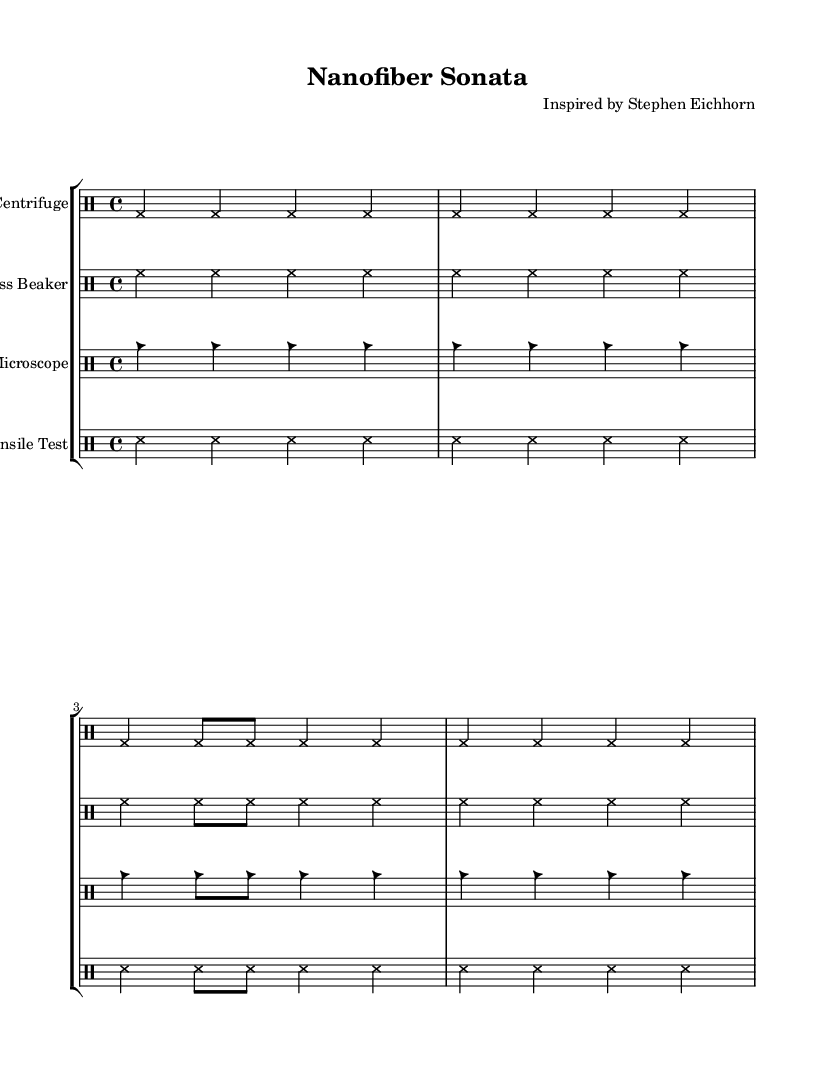What is the time signature of this music? The time signature is indicated by the quarter note beats per measure throughout the piece. Each measure consists of four beats, seen by the grouping of notes that repeat consistently.
Answer: 4/4 What is the instrument name for the first staff? The first staff is labeled as "Centrifuge," which is indicated at the beginning of that staff.
Answer: Centrifuge How many measures are in the "Glass Beaker" section? The "Glass Beaker" section contains four measures, similar to the other staffs in the composition, as indicated by the repeating pattern of the notation.
Answer: 4 Which note head style is used for the "Electron Microscope"? The "Electron Microscope" section uses a style indicated by square note heads, as defined in the code where the note head style is specified.
Answer: Square What instruments are featured in this composition? The instruments are listed at the beginning of each staff, and they include Centrifuge, Glass Beaker, Electron Microscope, and Tensile Test.
Answer: Centrifuge, Glass Beaker, Electron Microscope, Tensile Test Which note type is predominant in the "Tensile Testing Machine"? The notable note type in the "Tensile Testing Machine" is the sixteenth note, which shows the subdivision of the quarter notes and creates a rapid rhythmic texture.
Answer: Sixteenth note What is the overall style of this composition? The overall style can be recognized by the distinct sound-producing objects and unconventional notation styles for each staff, indicating an experimental nature.
Answer: Experimental 